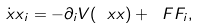Convert formula to latex. <formula><loc_0><loc_0><loc_500><loc_500>\dot { \ x x } _ { i } = - \partial _ { i } V ( \ x x ) + \ F F _ { i } ,</formula> 